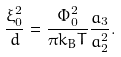Convert formula to latex. <formula><loc_0><loc_0><loc_500><loc_500>\frac { \xi _ { 0 } ^ { 2 } } { d } = \frac { \Phi _ { 0 } ^ { 2 } } { \pi k _ { B } T } \frac { a _ { 3 } } { a _ { 2 } ^ { 2 } } .</formula> 